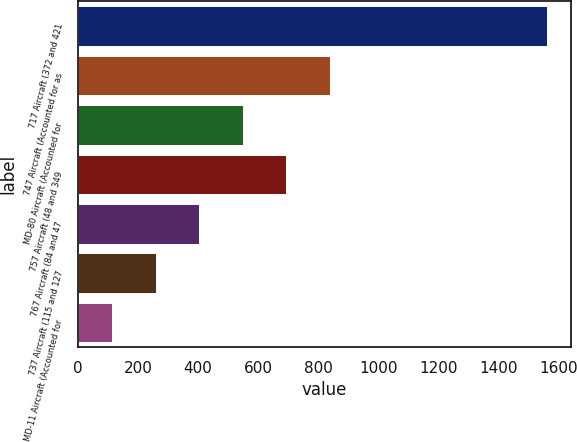<chart> <loc_0><loc_0><loc_500><loc_500><bar_chart><fcel>717 Aircraft (372 and 421<fcel>747 Aircraft (Accounted for as<fcel>MD-80 Aircraft (Accounted for<fcel>757 Aircraft (48 and 349<fcel>767 Aircraft (84 and 47<fcel>737 Aircraft (115 and 127<fcel>MD-11 Aircraft (Accounted for<nl><fcel>1562<fcel>838<fcel>548.4<fcel>693.2<fcel>403.6<fcel>258.8<fcel>114<nl></chart> 